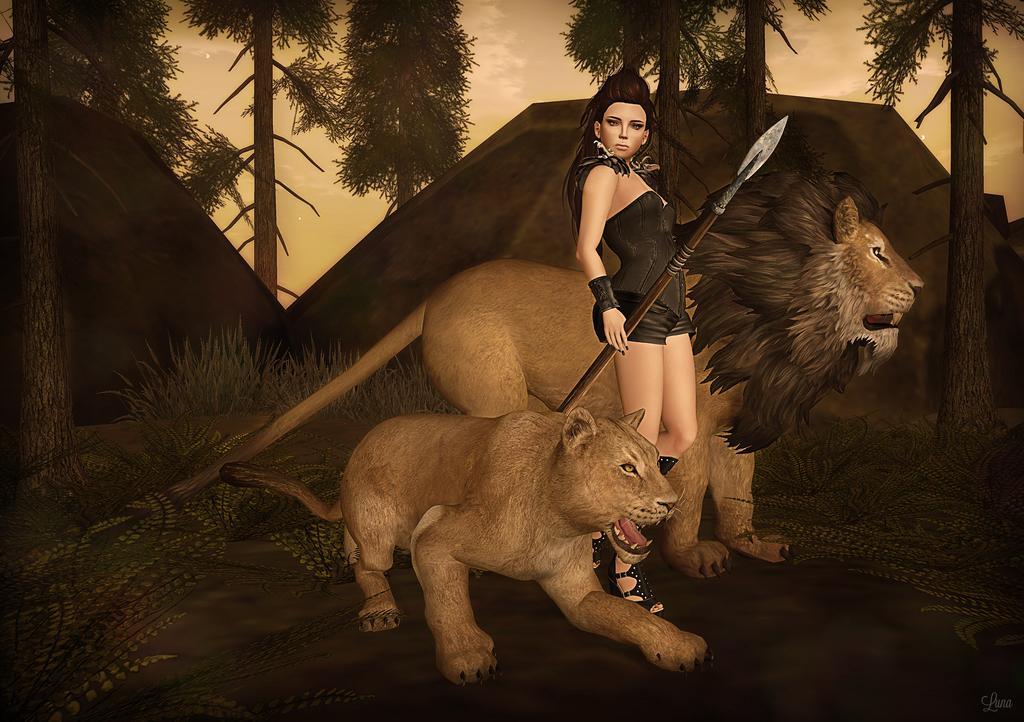Please provide a concise description of this image. In this image I can see it is an animation. In the middle a woman is standing with a weapon, beside her two animals are there. In the background I can see there are trees. At the top there is the sky. 